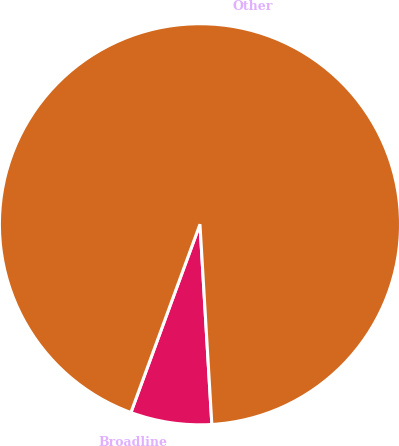<chart> <loc_0><loc_0><loc_500><loc_500><pie_chart><fcel>Broadline<fcel>Other<nl><fcel>6.54%<fcel>93.46%<nl></chart> 